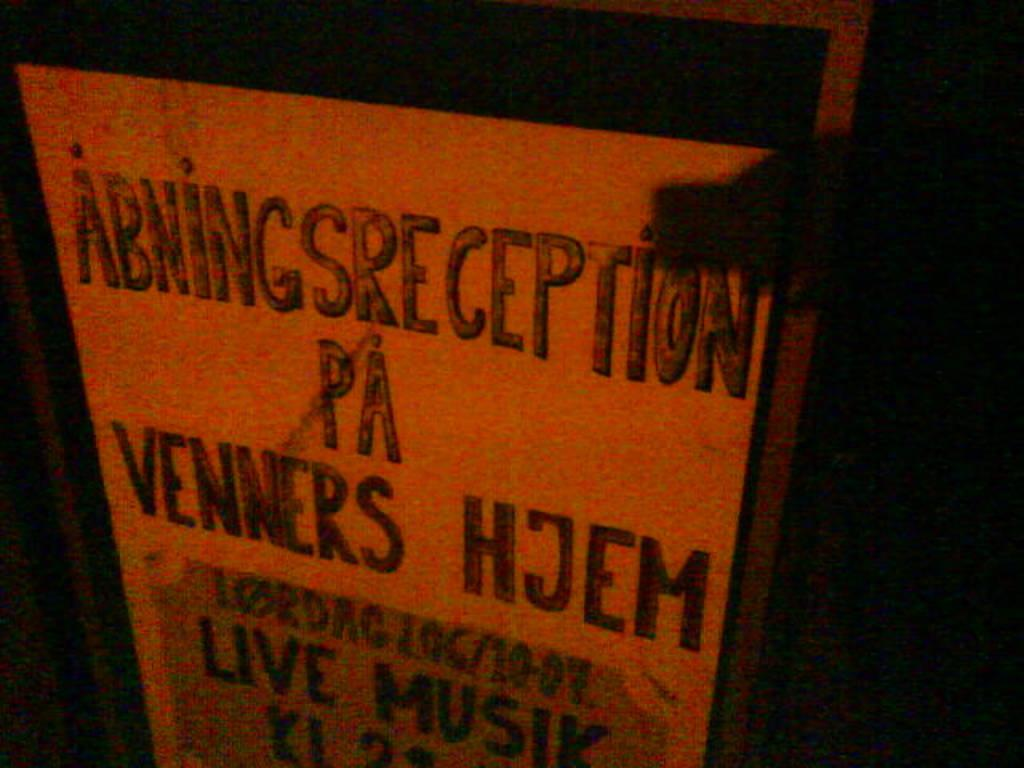<image>
Present a compact description of the photo's key features. White sign with black wording that say "Abningsreception pa venners hjem". 